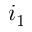<formula> <loc_0><loc_0><loc_500><loc_500>i _ { 1 }</formula> 